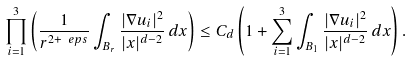<formula> <loc_0><loc_0><loc_500><loc_500>\prod _ { i = 1 } ^ { 3 } \left ( \frac { 1 } { r ^ { 2 + \ e p s } } \int _ { B _ { r } } \frac { | \nabla u _ { i } | ^ { 2 } } { | x | ^ { d - 2 } } \, d x \right ) \leq C _ { d } \left ( 1 + \sum _ { i = 1 } ^ { 3 } \int _ { B _ { 1 } } \frac { | \nabla u _ { i } | ^ { 2 } } { | x | ^ { d - 2 } } \, d x \right ) .</formula> 